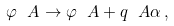<formula> <loc_0><loc_0><loc_500><loc_500>\varphi _ { \ } A \to \varphi _ { \ } A + q _ { \ } A \alpha \, ,</formula> 